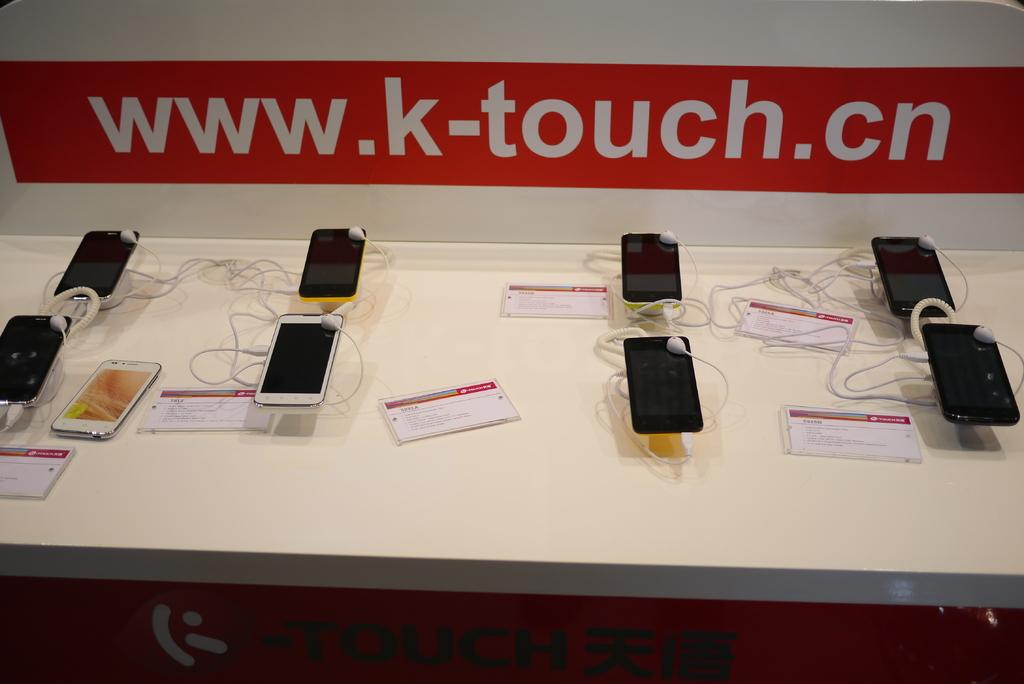Provide a one-sentence caption for the provided image. Several phones are displayed for sale under a sign that says www.k-touch.cn. 